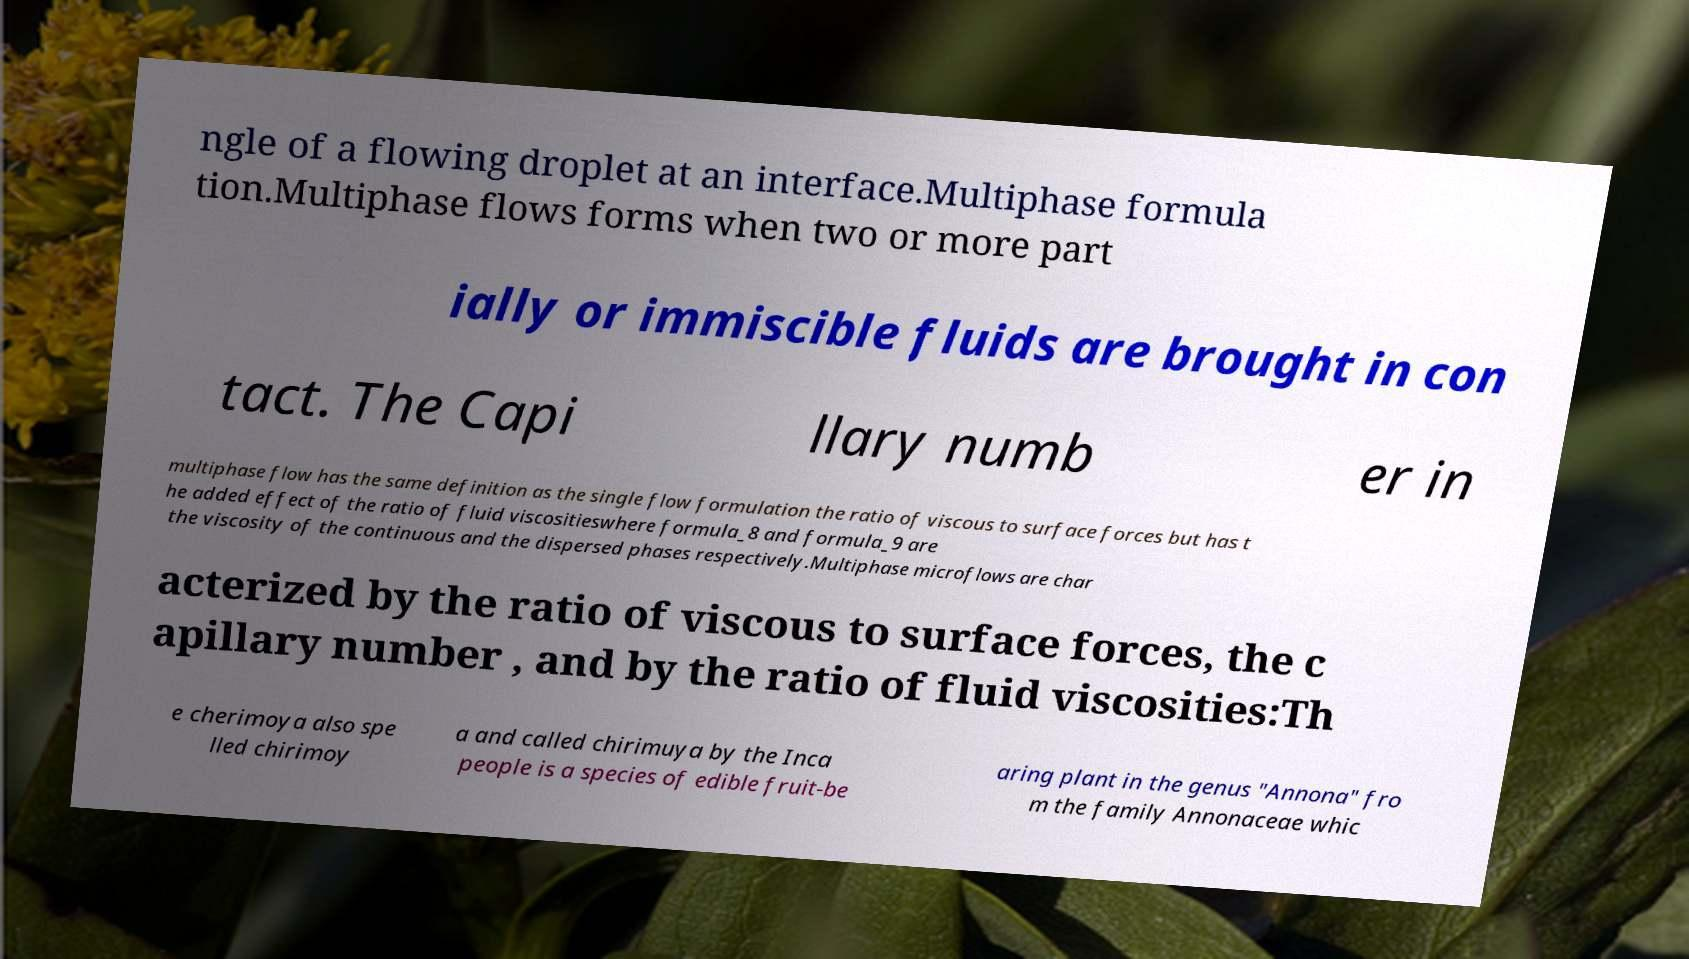Please read and relay the text visible in this image. What does it say? ngle of a flowing droplet at an interface.Multiphase formula tion.Multiphase flows forms when two or more part ially or immiscible fluids are brought in con tact. The Capi llary numb er in multiphase flow has the same definition as the single flow formulation the ratio of viscous to surface forces but has t he added effect of the ratio of fluid viscositieswhere formula_8 and formula_9 are the viscosity of the continuous and the dispersed phases respectively.Multiphase microflows are char acterized by the ratio of viscous to surface forces, the c apillary number , and by the ratio of fluid viscosities:Th e cherimoya also spe lled chirimoy a and called chirimuya by the Inca people is a species of edible fruit-be aring plant in the genus "Annona" fro m the family Annonaceae whic 